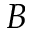<formula> <loc_0><loc_0><loc_500><loc_500>B</formula> 